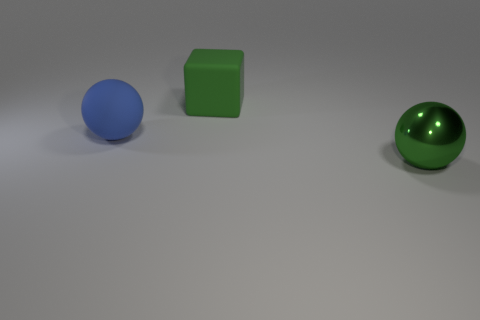Add 3 large purple cylinders. How many objects exist? 6 Subtract all spheres. How many objects are left? 1 Subtract all big green objects. Subtract all big blue matte objects. How many objects are left? 0 Add 1 green matte blocks. How many green matte blocks are left? 2 Add 3 blue matte balls. How many blue matte balls exist? 4 Subtract 1 green spheres. How many objects are left? 2 